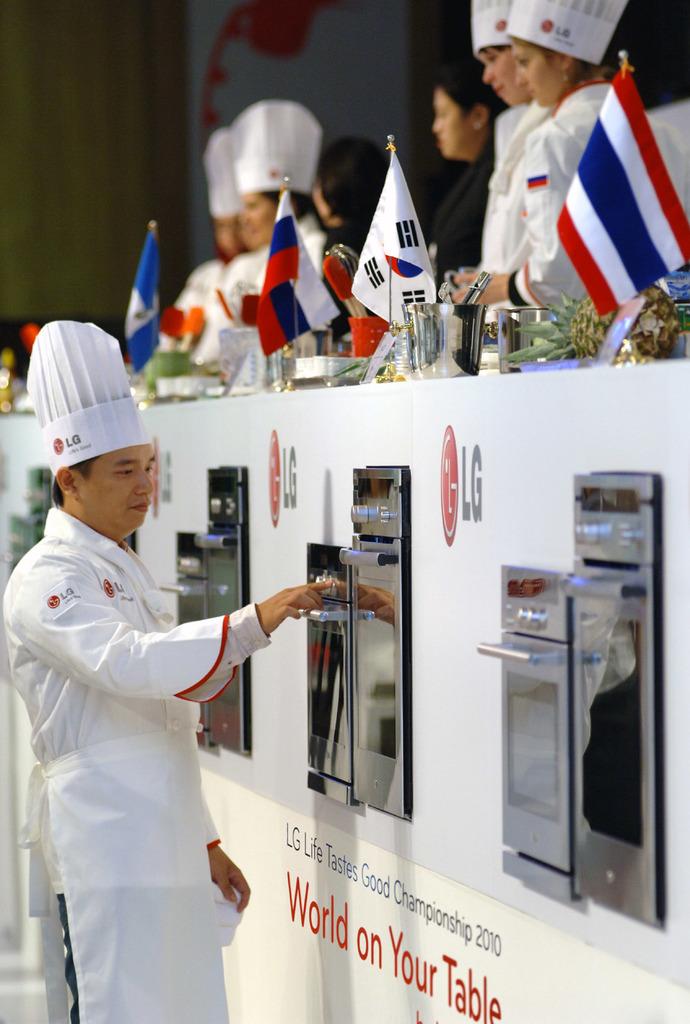What brand is shown in this picture?
Ensure brevity in your answer.  Lg. What is on your table?
Your answer should be compact. World. 